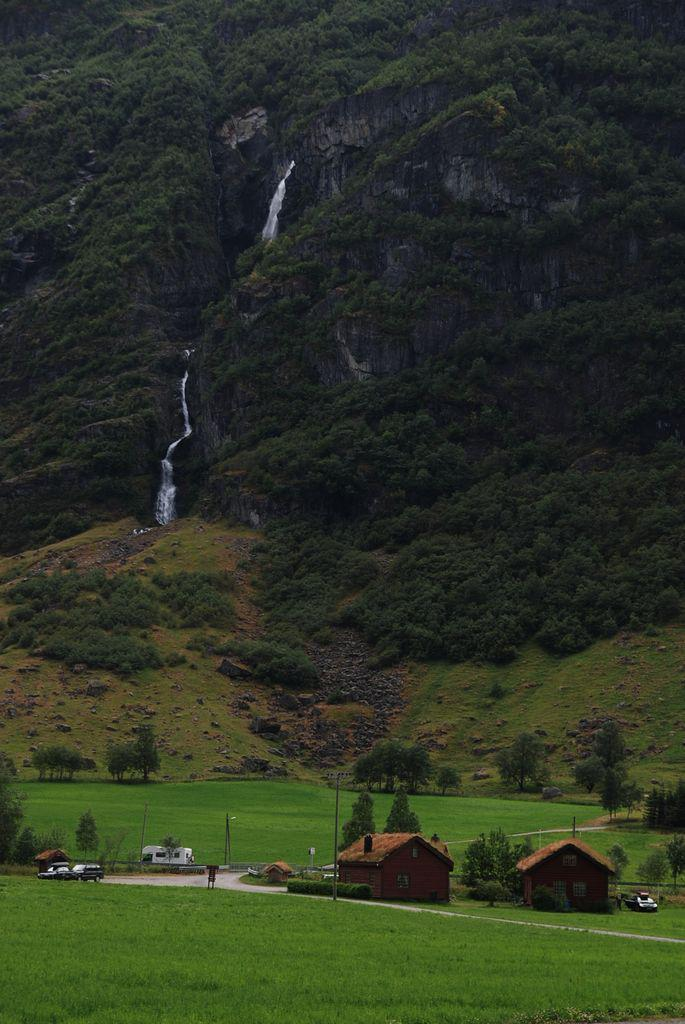What type of landscape is depicted in the image? The image features fields. What structures can be seen in the middle of the image? There are houses in the middle of the image. What can be seen in the background of the image? There are trees, a waterfall, and a mountain in the background of the image. What type of books can be found in the library in the image? There is no library present in the image. What time of day is it in the image, considering the presence of the afternoon? The image does not specify the time of day, and there is no mention of an afternoon in the provided facts. 